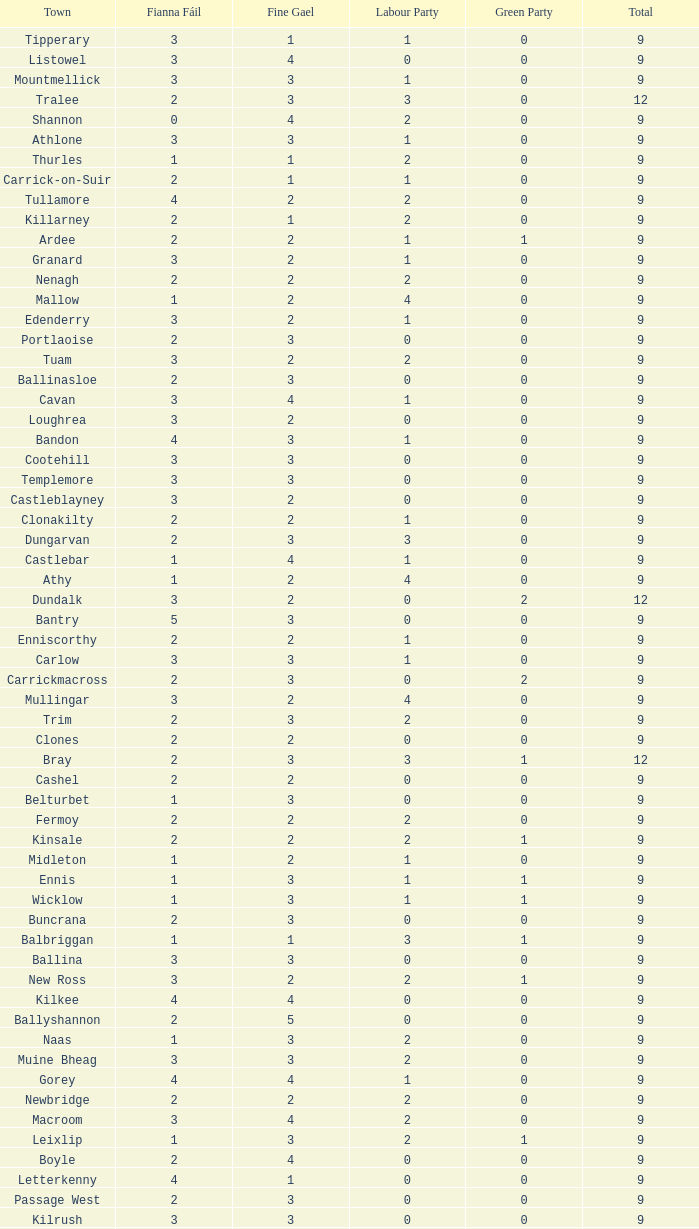What is the lowest number in the Labour Party for the Fianna Fail higher than 5? None. 